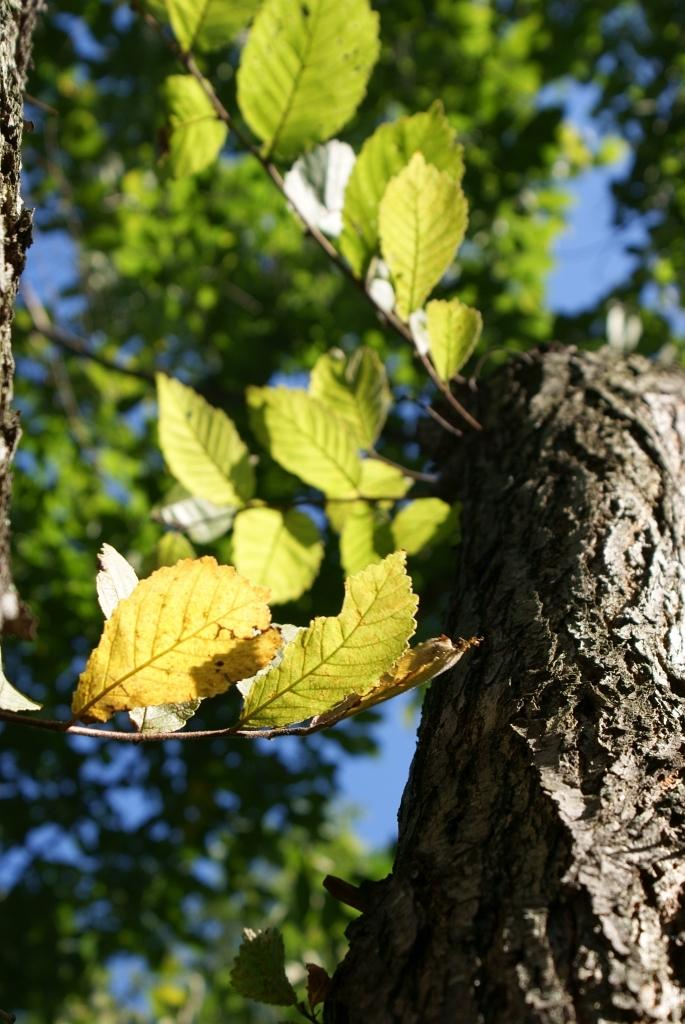What type of vegetation can be seen in the image? There are trees in the image. What part of the natural environment is visible in the image? The sky is visible in the image. What type of prison can be seen in the image? There is no prison present in the image; it features trees and the sky. What type of spark can be seen coming from the trees in the image? There is no spark present in the image; it only features trees and the sky. 